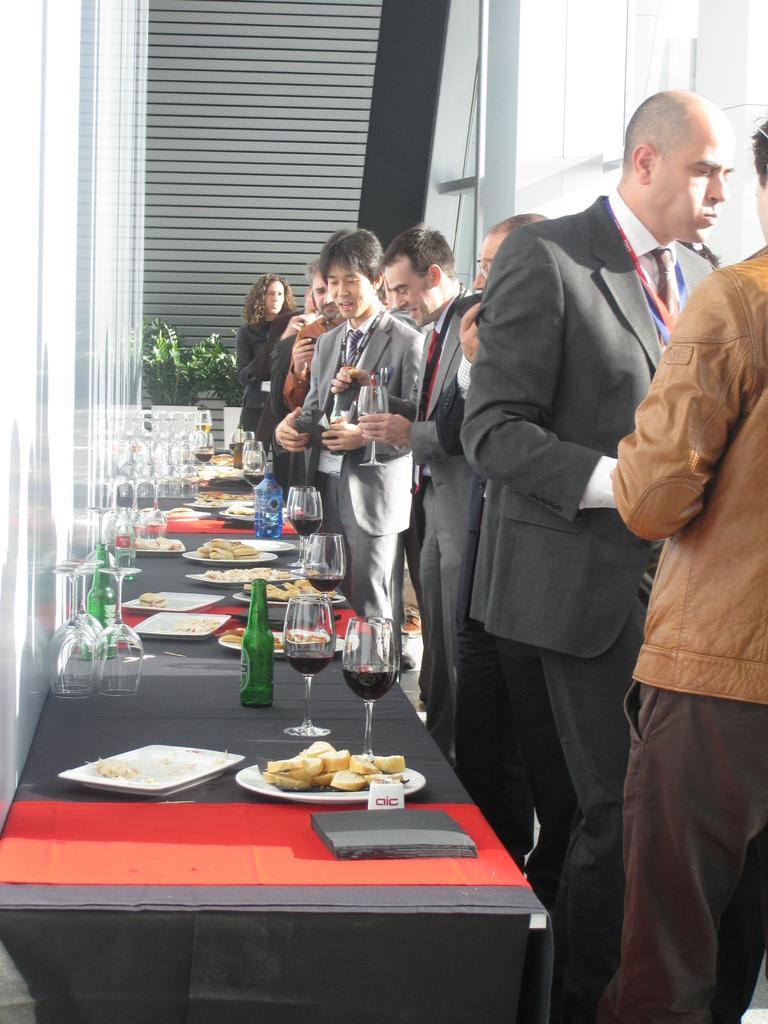Can you describe this image briefly? This is a picture taken in a hotel, there are a group of people standing on the floor in front of the people there is a table which is in black color on the table there is a bottle, glass, plate, fork and a flower pot. Background of this people there is a window glass. 